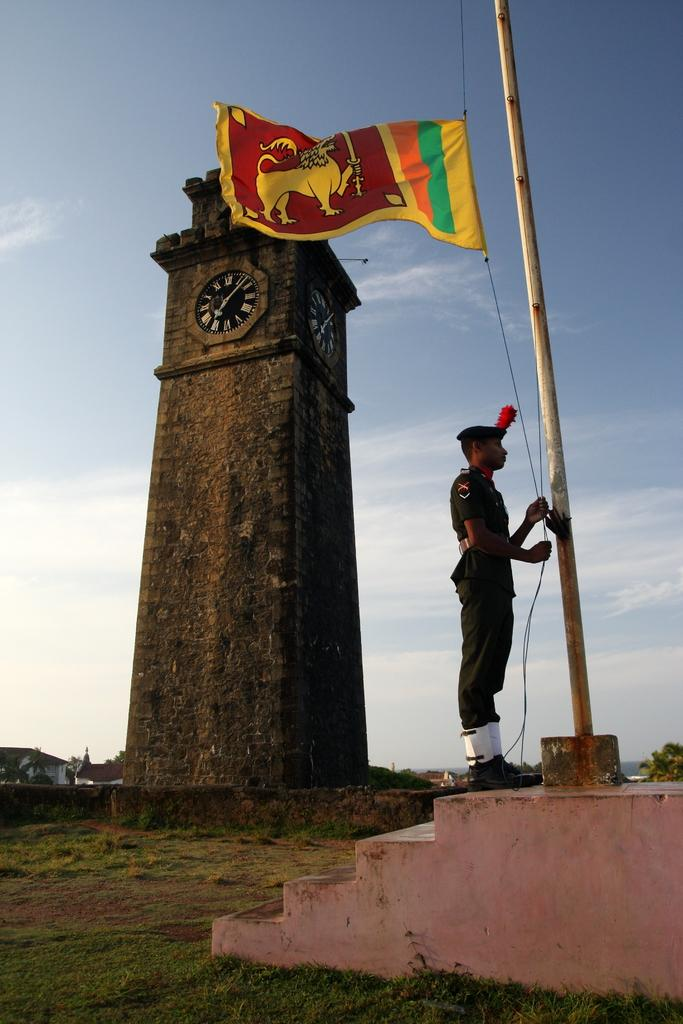What is the main subject in the foreground of the image? There is a man in the foreground of the image. What is the man doing in the image? The man is hoisting a flag. What architectural feature can be seen in the image? There are stairs in the image. What type of vegetation is present in the image? There is grass in the image. What can be seen in the background of the image? There is a clock tower, buildings, and the sky visible in the background of the image. How many ladybugs are crawling on the clock tower in the image? There are no ladybugs present on the clock tower in the image. Can you hear the bell ringing in the image? There is no bell ringing in the image, as it does not mention any bells or sounds. 